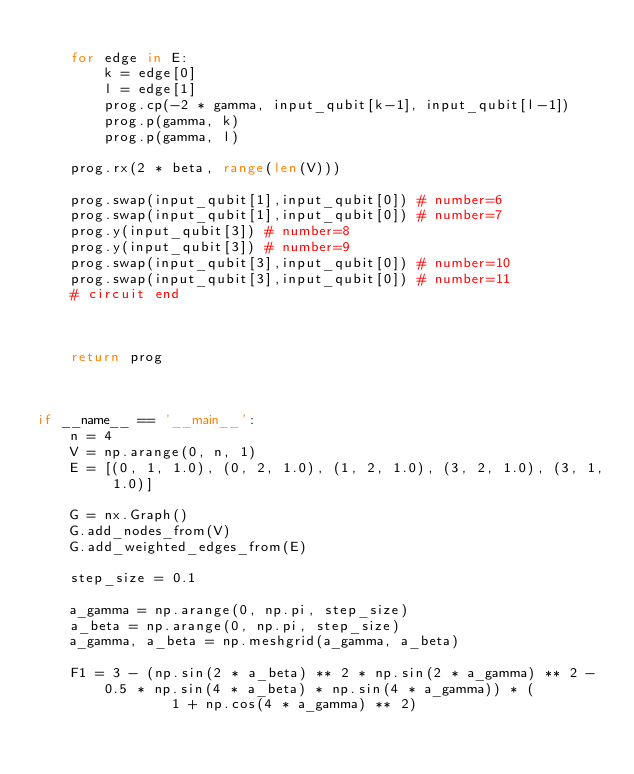<code> <loc_0><loc_0><loc_500><loc_500><_Python_>
    for edge in E:
        k = edge[0]
        l = edge[1]
        prog.cp(-2 * gamma, input_qubit[k-1], input_qubit[l-1])
        prog.p(gamma, k)
        prog.p(gamma, l)

    prog.rx(2 * beta, range(len(V)))

    prog.swap(input_qubit[1],input_qubit[0]) # number=6
    prog.swap(input_qubit[1],input_qubit[0]) # number=7
    prog.y(input_qubit[3]) # number=8
    prog.y(input_qubit[3]) # number=9
    prog.swap(input_qubit[3],input_qubit[0]) # number=10
    prog.swap(input_qubit[3],input_qubit[0]) # number=11
    # circuit end



    return prog



if __name__ == '__main__':
    n = 4
    V = np.arange(0, n, 1)
    E = [(0, 1, 1.0), (0, 2, 1.0), (1, 2, 1.0), (3, 2, 1.0), (3, 1, 1.0)]

    G = nx.Graph()
    G.add_nodes_from(V)
    G.add_weighted_edges_from(E)

    step_size = 0.1

    a_gamma = np.arange(0, np.pi, step_size)
    a_beta = np.arange(0, np.pi, step_size)
    a_gamma, a_beta = np.meshgrid(a_gamma, a_beta)

    F1 = 3 - (np.sin(2 * a_beta) ** 2 * np.sin(2 * a_gamma) ** 2 - 0.5 * np.sin(4 * a_beta) * np.sin(4 * a_gamma)) * (
                1 + np.cos(4 * a_gamma) ** 2)
</code> 